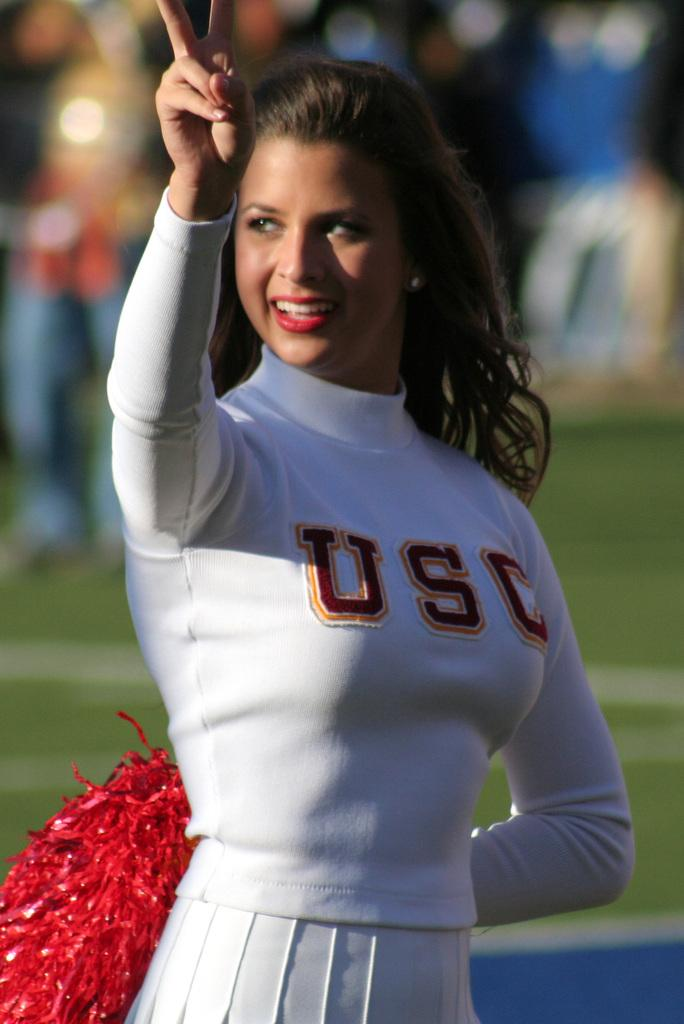Provide a one-sentence caption for the provided image. A brunette cheerleader from USC with red pom poms. 